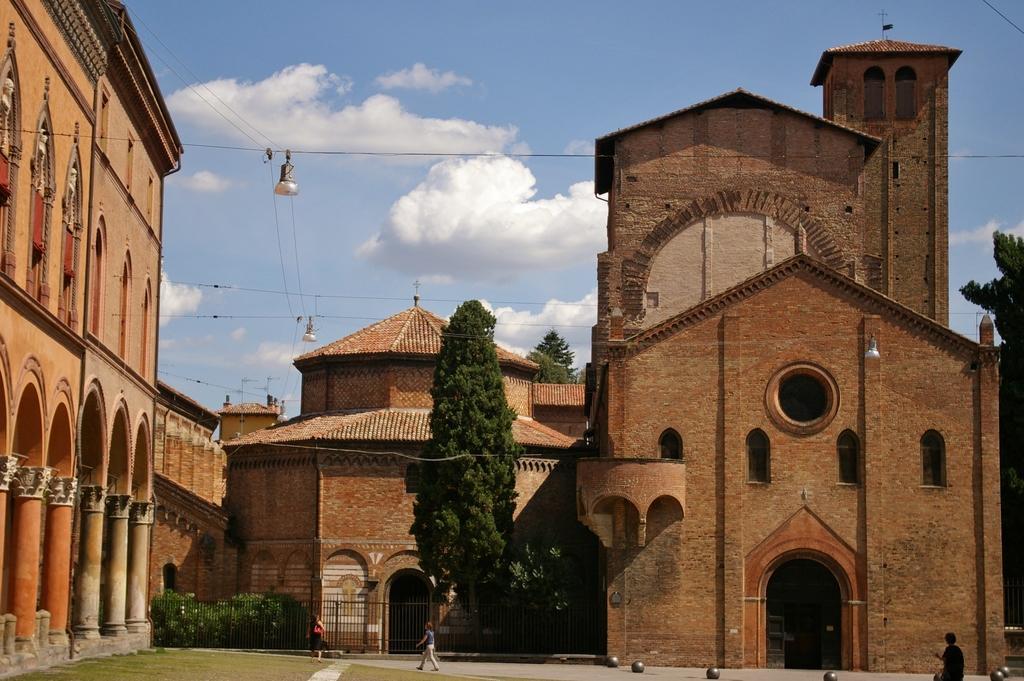Please provide a concise description of this image. In this image we can see buildings, trees. At the bottom of the image there are people. At the top of the image there is sky and clouds. 